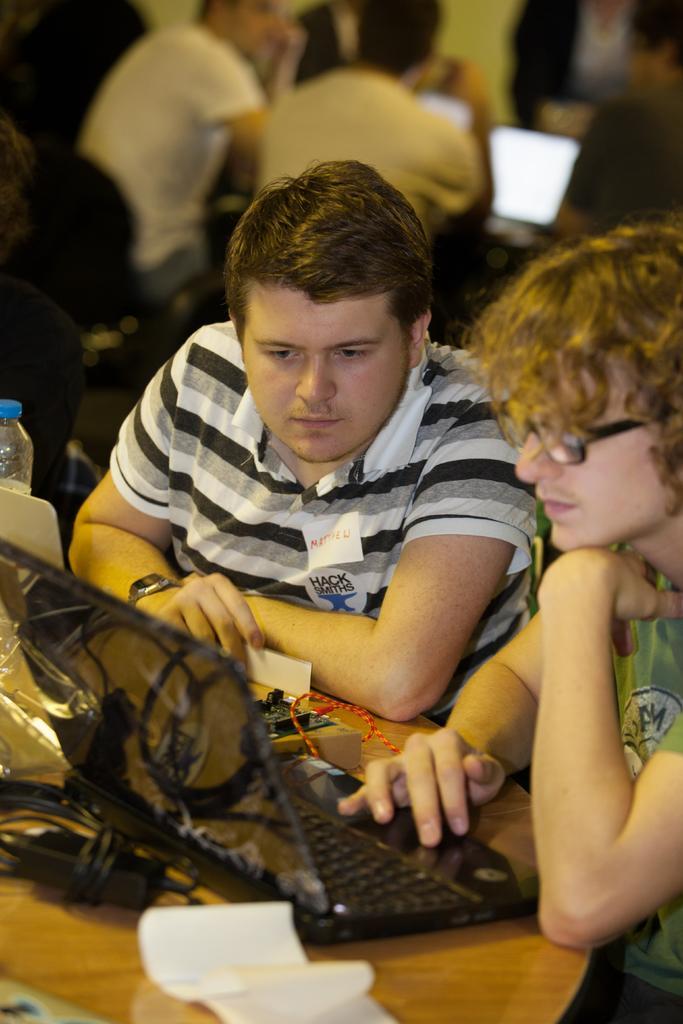Describe this image in one or two sentences. In the image we can see there are people who are sitting on chair and on table there is keyboard, monitor, papers and water bottle. 